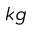Convert formula to latex. <formula><loc_0><loc_0><loc_500><loc_500>k g</formula> 